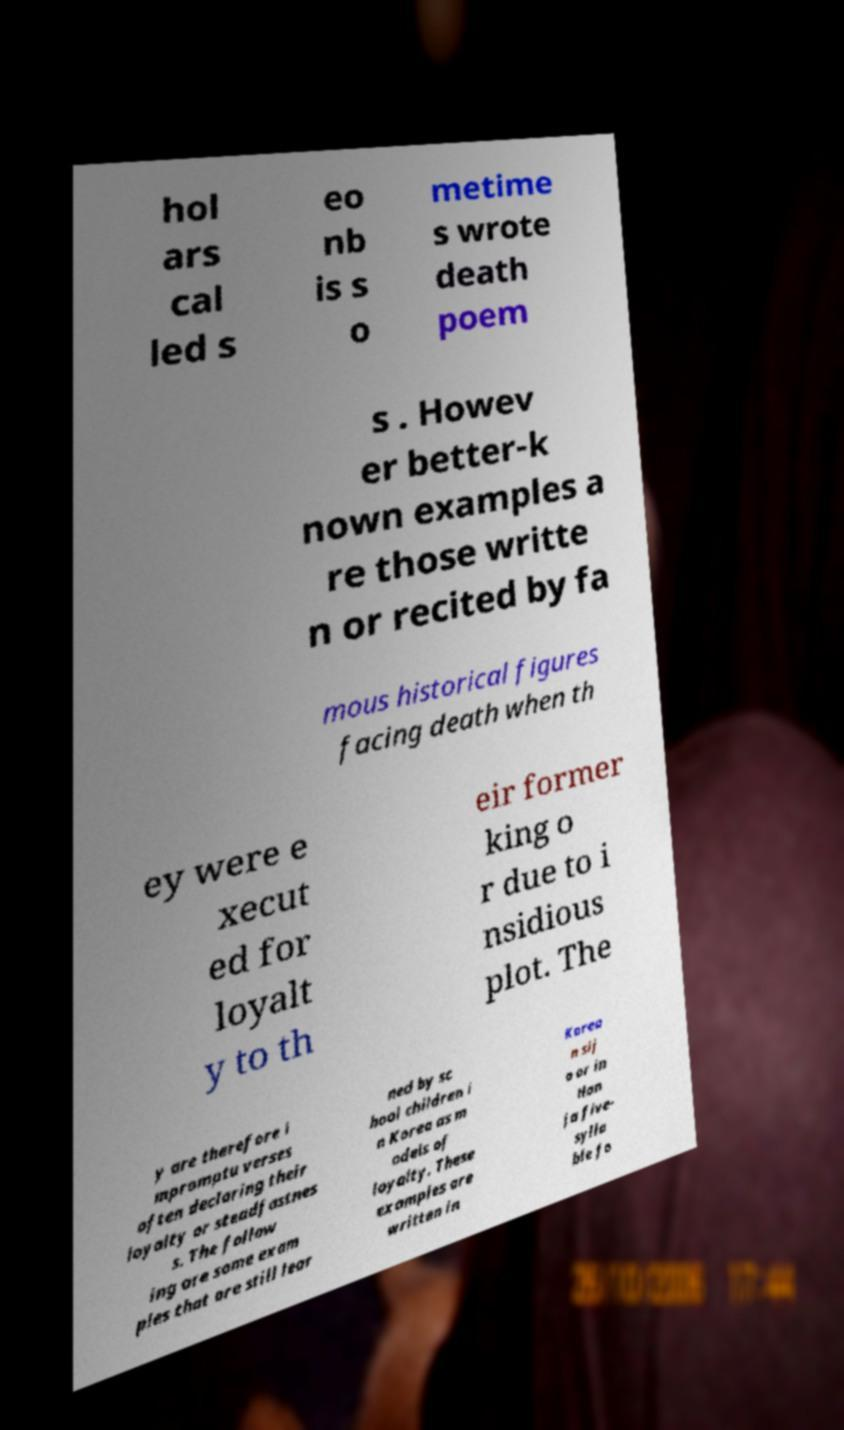Can you read and provide the text displayed in the image?This photo seems to have some interesting text. Can you extract and type it out for me? hol ars cal led s eo nb is s o metime s wrote death poem s . Howev er better-k nown examples a re those writte n or recited by fa mous historical figures facing death when th ey were e xecut ed for loyalt y to th eir former king o r due to i nsidious plot. The y are therefore i mpromptu verses often declaring their loyalty or steadfastnes s. The follow ing are some exam ples that are still lear ned by sc hool children i n Korea as m odels of loyalty. These examples are written in Korea n sij o or in Han ja five- sylla ble fo 